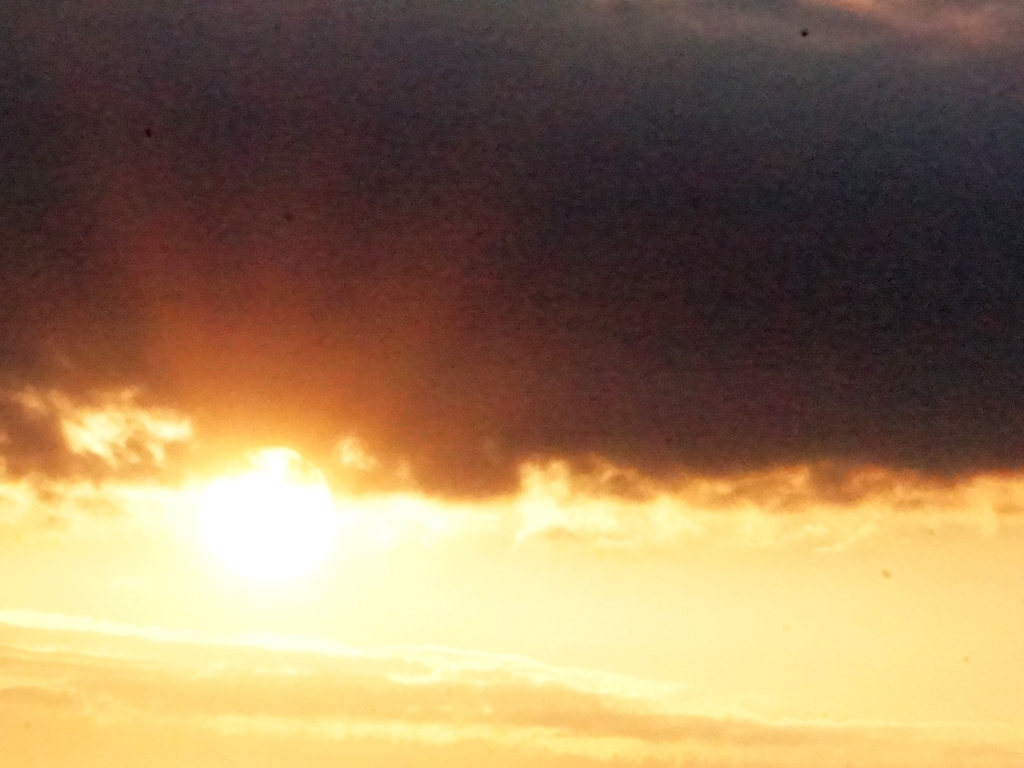What time of day does this image convey? This image suggests it is either dawn or dusk, as the sun is low on the horizon, casting a warm glow and creating a silhouette with long shadows. 